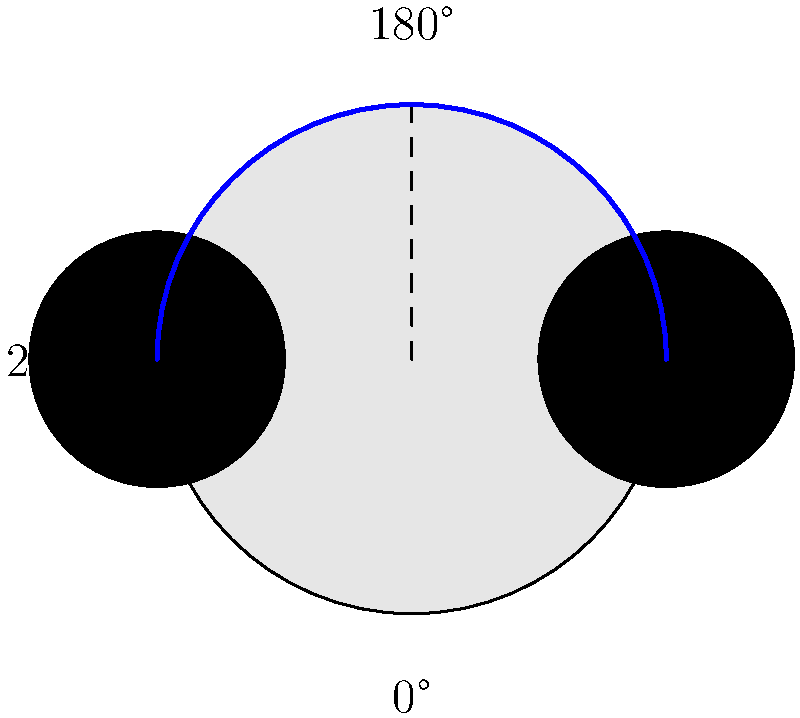Mickey Mouse's head is made up of one large circle for the face and two smaller circles for the ears. If we start with the ears at 0° and 180° positions, how many degrees should we rotate the ears clockwise to create a symmetrical design where the ears are at 90° and 270° positions? Let's approach this step-by-step:

1) The initial position of the ears is at 0° and 180°.
2) We want to move the ears to 90° and 270°.
3) To find the rotation angle, we need to calculate how far each ear needs to move:
   - The ear at 0° needs to move to 90°, which is a 90° clockwise rotation.
   - The ear at 180° needs to move to 270°, which is also a 90° clockwise rotation.
4) Both ears need to rotate by the same amount to maintain symmetry.
5) Therefore, we need to rotate both ears by 90° clockwise.

The clockwise rotation of 90° will move the ear at 0° to 90°, and the ear at 180° to 270°, creating the desired symmetrical design.
Answer: 90° 